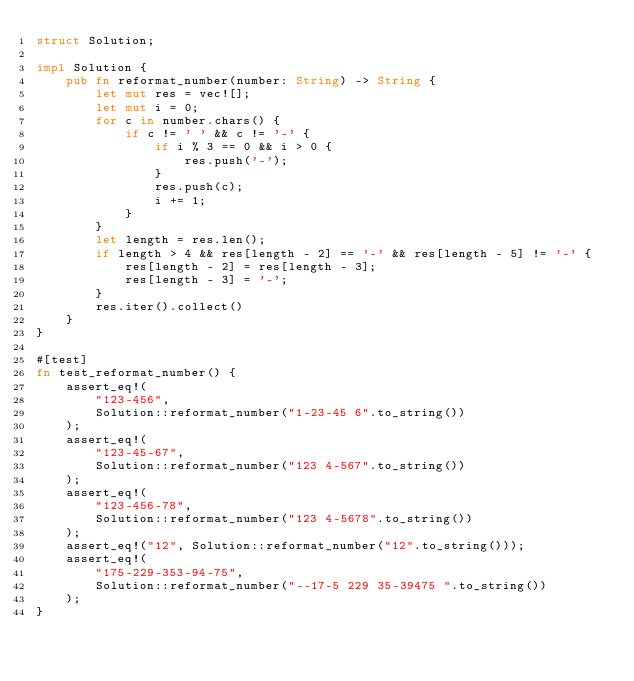Convert code to text. <code><loc_0><loc_0><loc_500><loc_500><_Rust_>struct Solution;

impl Solution {
    pub fn reformat_number(number: String) -> String {
        let mut res = vec![];
        let mut i = 0;
        for c in number.chars() {
            if c != ' ' && c != '-' {
                if i % 3 == 0 && i > 0 {
                    res.push('-');
                }
                res.push(c);
                i += 1;
            }
        }
        let length = res.len();
        if length > 4 && res[length - 2] == '-' && res[length - 5] != '-' {
            res[length - 2] = res[length - 3];
            res[length - 3] = '-';
        }
        res.iter().collect()
    }
}

#[test]
fn test_reformat_number() {
    assert_eq!(
        "123-456",
        Solution::reformat_number("1-23-45 6".to_string())
    );
    assert_eq!(
        "123-45-67",
        Solution::reformat_number("123 4-567".to_string())
    );
    assert_eq!(
        "123-456-78",
        Solution::reformat_number("123 4-5678".to_string())
    );
    assert_eq!("12", Solution::reformat_number("12".to_string()));
    assert_eq!(
        "175-229-353-94-75",
        Solution::reformat_number("--17-5 229 35-39475 ".to_string())
    );
}
</code> 